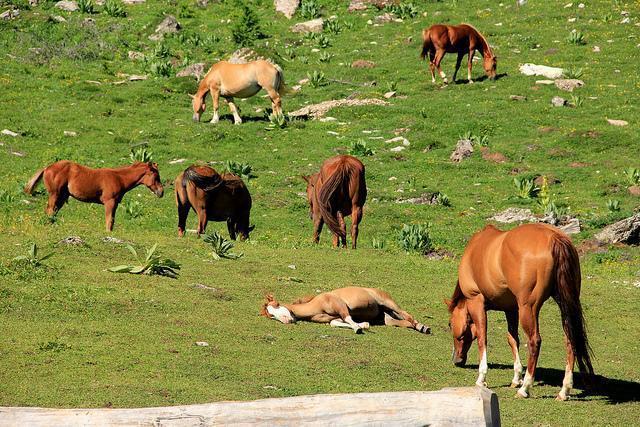How many horses?
Give a very brief answer. 7. How many horses are visible?
Give a very brief answer. 7. How many elephants are standing in this picture?
Give a very brief answer. 0. 